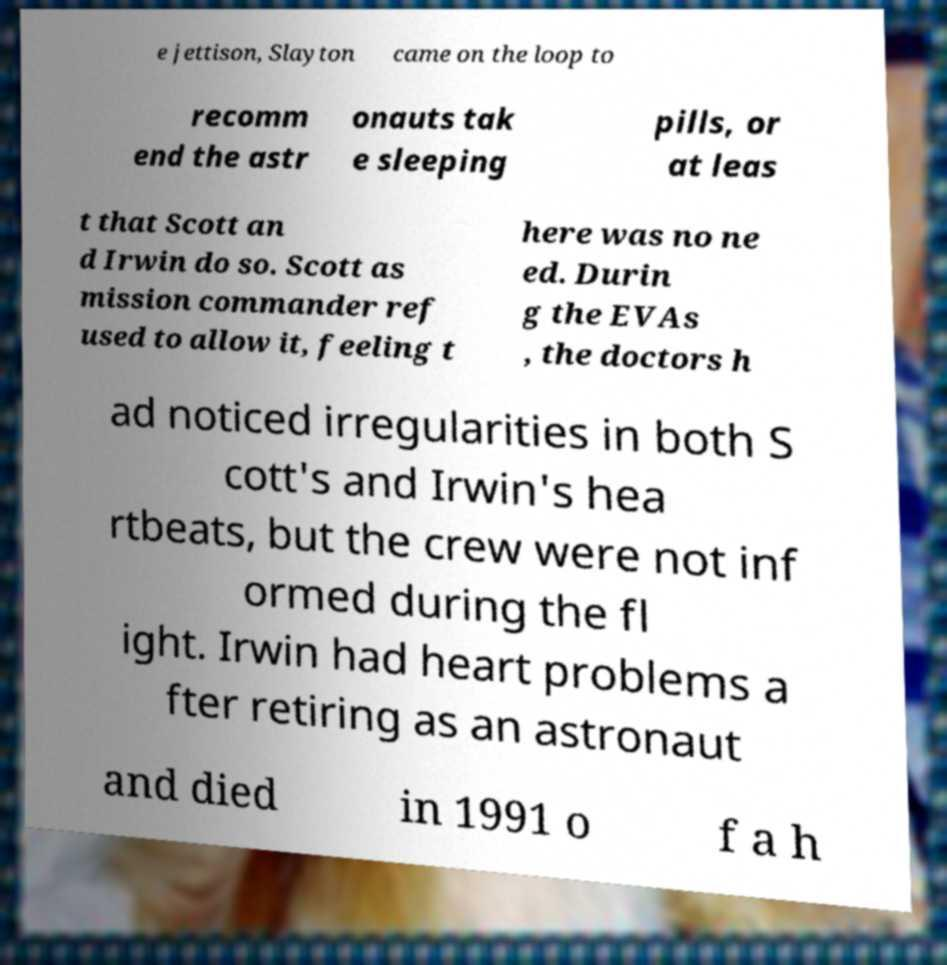Please identify and transcribe the text found in this image. e jettison, Slayton came on the loop to recomm end the astr onauts tak e sleeping pills, or at leas t that Scott an d Irwin do so. Scott as mission commander ref used to allow it, feeling t here was no ne ed. Durin g the EVAs , the doctors h ad noticed irregularities in both S cott's and Irwin's hea rtbeats, but the crew were not inf ormed during the fl ight. Irwin had heart problems a fter retiring as an astronaut and died in 1991 o f a h 